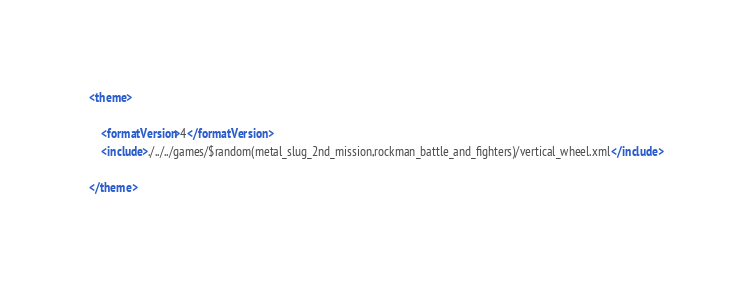<code> <loc_0><loc_0><loc_500><loc_500><_XML_><theme>

	<formatVersion>4</formatVersion>
	<include>./../../games/$random(metal_slug_2nd_mission,rockman_battle_and_fighters)/vertical_wheel.xml</include>

</theme></code> 